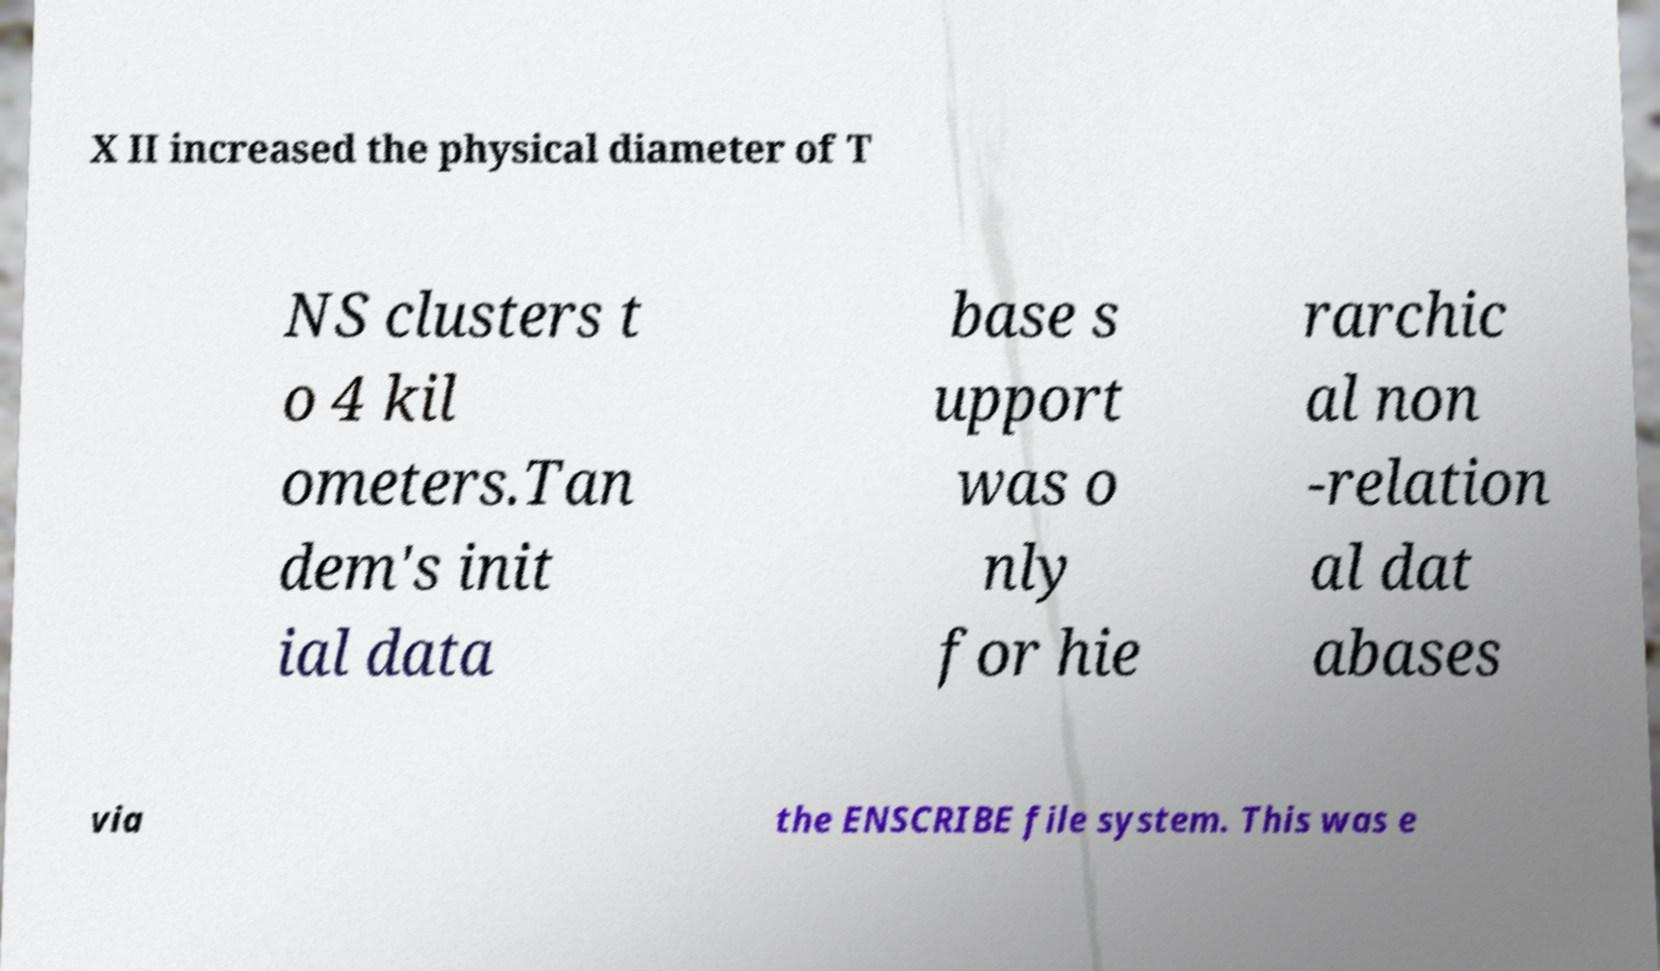I need the written content from this picture converted into text. Can you do that? X II increased the physical diameter of T NS clusters t o 4 kil ometers.Tan dem's init ial data base s upport was o nly for hie rarchic al non -relation al dat abases via the ENSCRIBE file system. This was e 